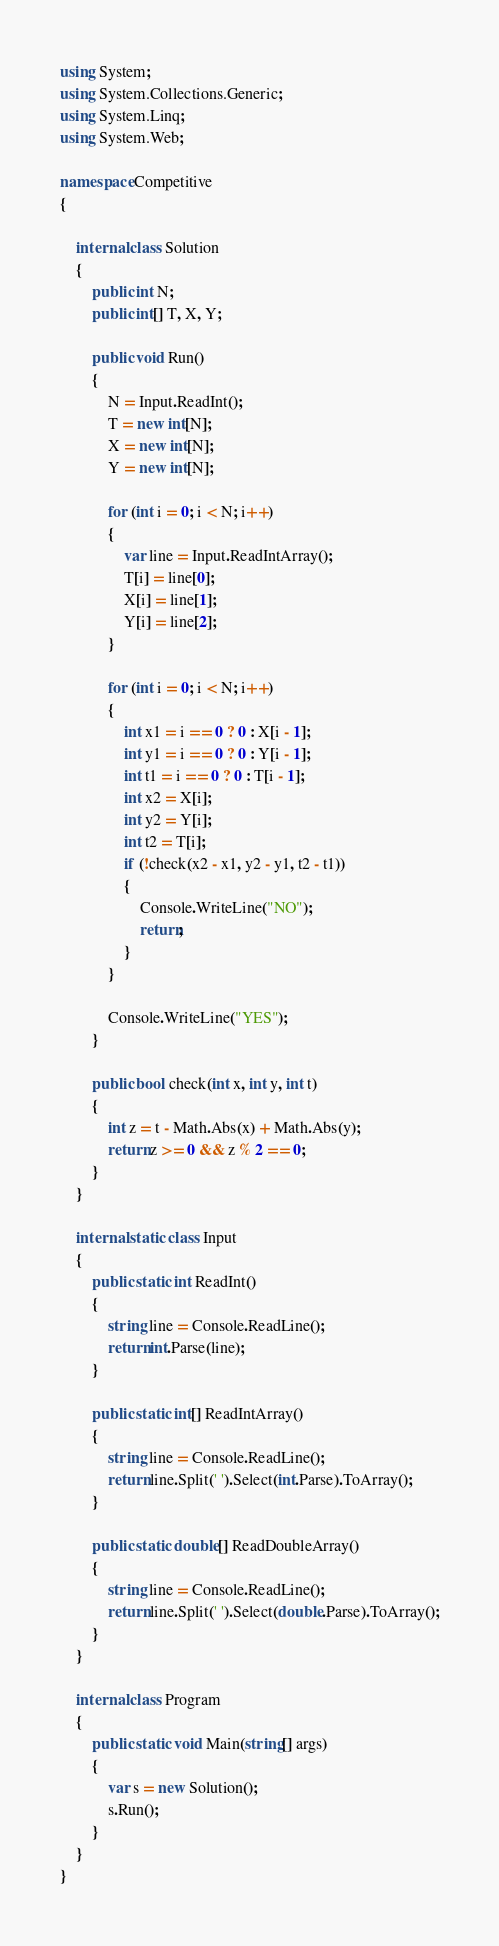Convert code to text. <code><loc_0><loc_0><loc_500><loc_500><_C#_>using System;
using System.Collections.Generic;
using System.Linq;
using System.Web;

namespace Competitive
{

    internal class Solution
    {
        public int N;
        public int[] T, X, Y;

        public void Run()
        {
            N = Input.ReadInt();
            T = new int[N];
            X = new int[N];
            Y = new int[N];

            for (int i = 0; i < N; i++)
            {
                var line = Input.ReadIntArray();
                T[i] = line[0];
                X[i] = line[1];
                Y[i] = line[2];
            }

            for (int i = 0; i < N; i++)
            {
                int x1 = i == 0 ? 0 : X[i - 1];
                int y1 = i == 0 ? 0 : Y[i - 1];
                int t1 = i == 0 ? 0 : T[i - 1];
                int x2 = X[i];
                int y2 = Y[i];
                int t2 = T[i];
                if (!check(x2 - x1, y2 - y1, t2 - t1))
                {
                    Console.WriteLine("NO");
                    return;
                }
            }

            Console.WriteLine("YES");
        }

        public bool check(int x, int y, int t)
        {
            int z = t - Math.Abs(x) + Math.Abs(y);
            return z >= 0 && z % 2 == 0;
        }
    }

    internal static class Input
    {
        public static int ReadInt()
        {
            string line = Console.ReadLine();
            return int.Parse(line);
        }

        public static int[] ReadIntArray()
        {
            string line = Console.ReadLine();
            return line.Split(' ').Select(int.Parse).ToArray();
        }

        public static double[] ReadDoubleArray()
        {
            string line = Console.ReadLine();
            return line.Split(' ').Select(double.Parse).ToArray();
        }
    }

    internal class Program
    {
        public static void Main(string[] args)
        {
            var s = new Solution();
            s.Run();
        }
    }
}</code> 